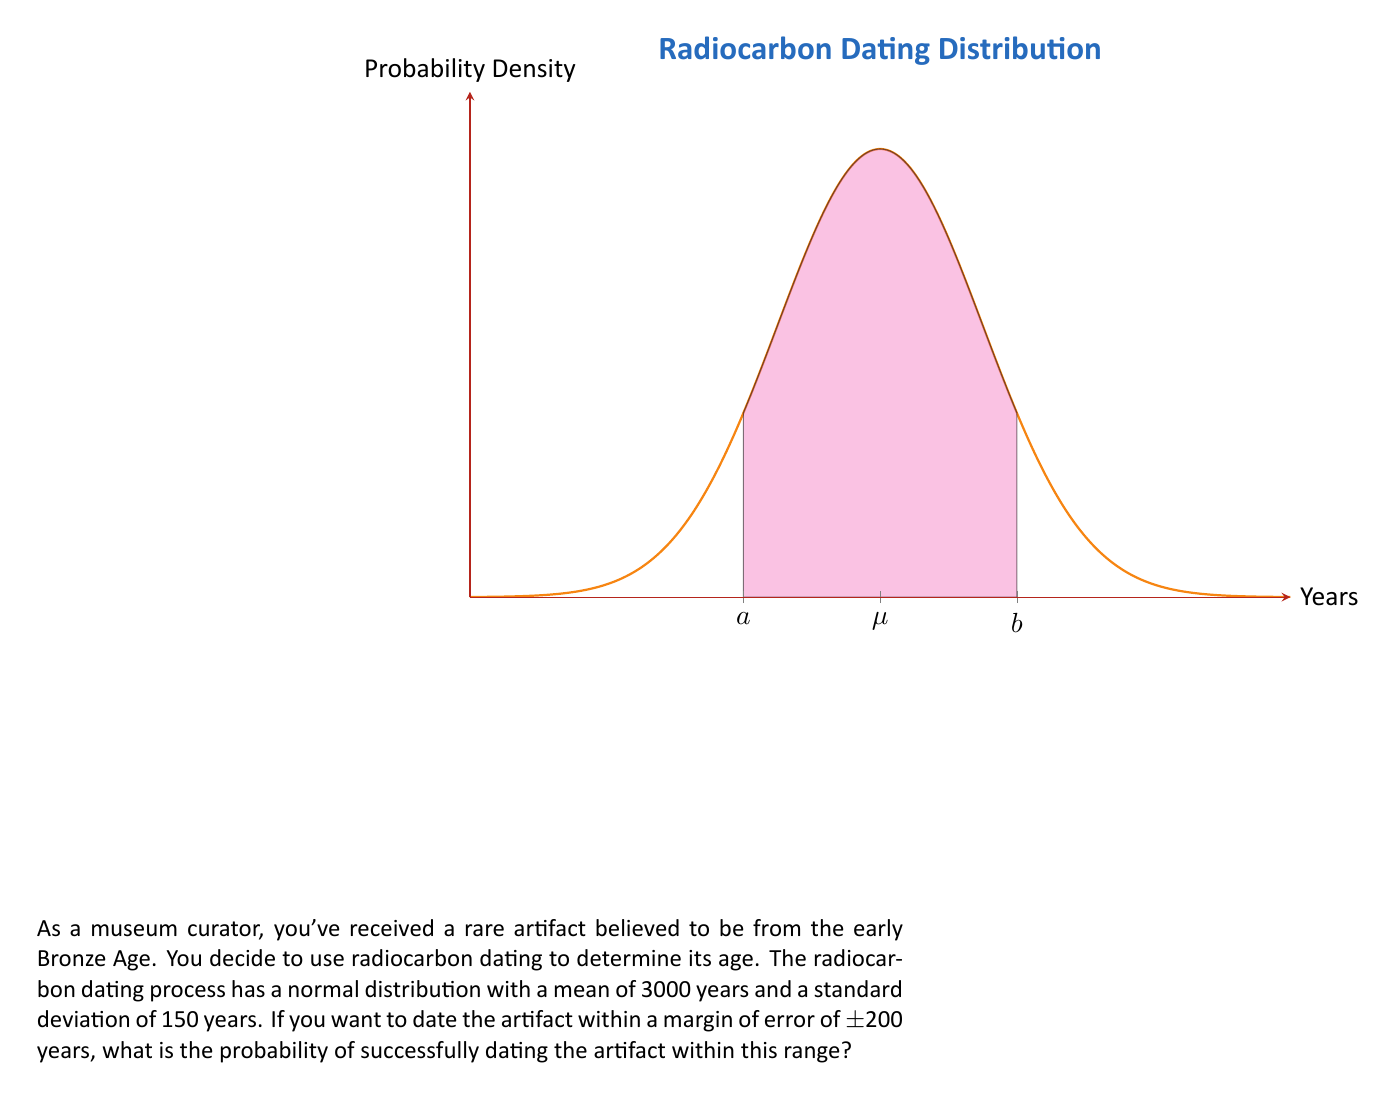What is the answer to this math problem? Let's approach this step-by-step:

1) We're dealing with a normal distribution where:
   $\mu = 3000$ years (mean)
   $\sigma = 150$ years (standard deviation)

2) We want to find the probability of dating within ±200 years of the true age. This means we're looking for the probability that the date falls between:
   $a = 3000 - 200 = 2800$ years and
   $b = 3000 + 200 = 3200$ years

3) To find this probability, we need to calculate the z-scores for these boundaries:

   For $a$: $z_a = \frac{2800 - 3000}{150} = -\frac{200}{150} = -1.33$
   For $b$: $z_b = \frac{3200 - 3000}{150} = \frac{200}{150} = 1.33$

4) The probability we're looking for is the area under the standard normal curve between these two z-scores:

   $P(-1.33 < Z < 1.33)$

5) This can be calculated as:

   $P(Z < 1.33) - P(Z < -1.33)$

6) Using a standard normal table or calculator:

   $P(Z < 1.33) = 0.9082$
   $P(Z < -1.33) = 0.0918$

7) Therefore, the probability is:

   $0.9082 - 0.0918 = 0.8164$

Thus, there's approximately an 81.64% chance of successfully dating the artifact within the specified margin of error.
Answer: $0.8164$ or $81.64\%$ 